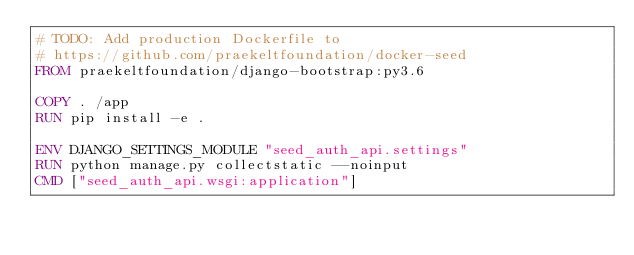<code> <loc_0><loc_0><loc_500><loc_500><_Dockerfile_># TODO: Add production Dockerfile to
# https://github.com/praekeltfoundation/docker-seed
FROM praekeltfoundation/django-bootstrap:py3.6

COPY . /app
RUN pip install -e .

ENV DJANGO_SETTINGS_MODULE "seed_auth_api.settings"
RUN python manage.py collectstatic --noinput
CMD ["seed_auth_api.wsgi:application"]
</code> 